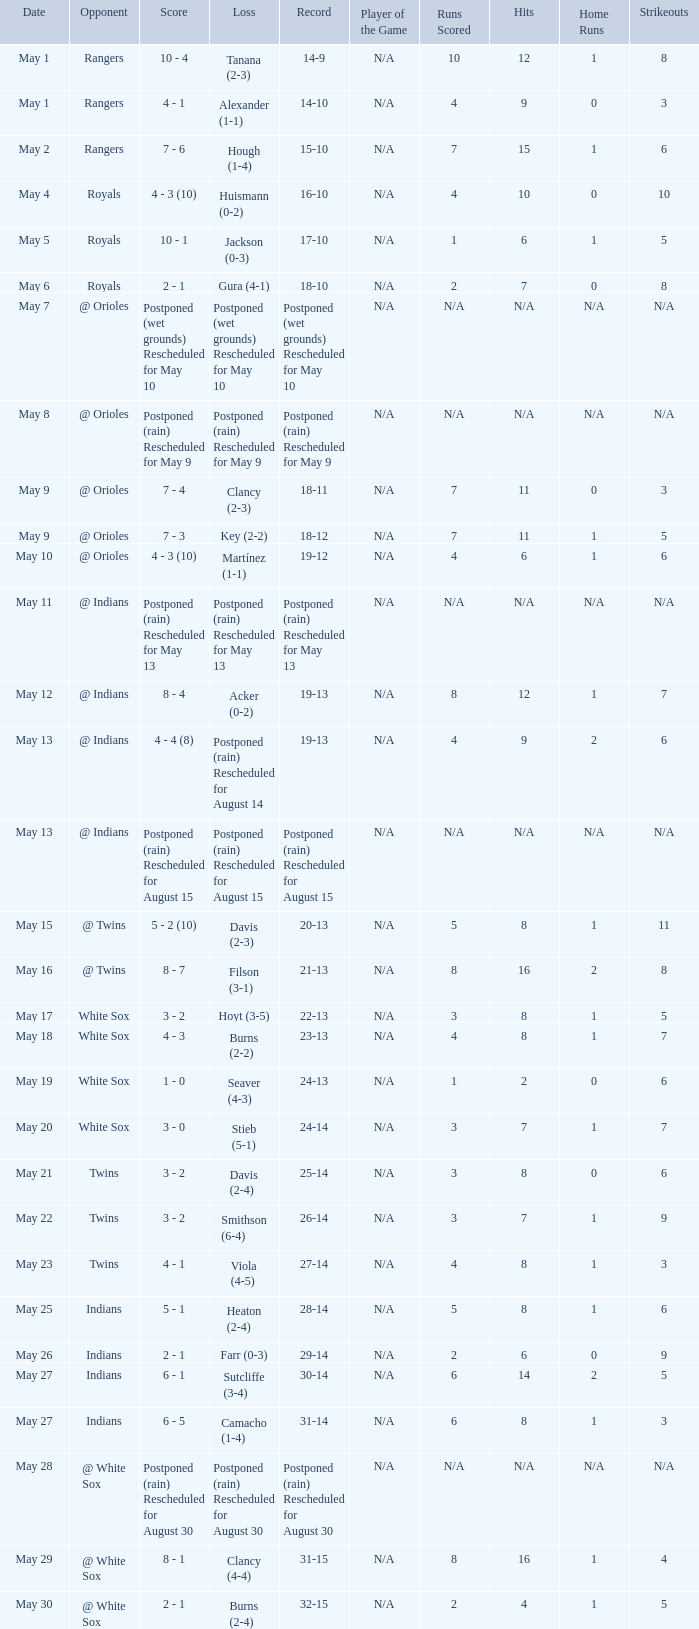What was date of the game when the record was 31-15? May 29. 